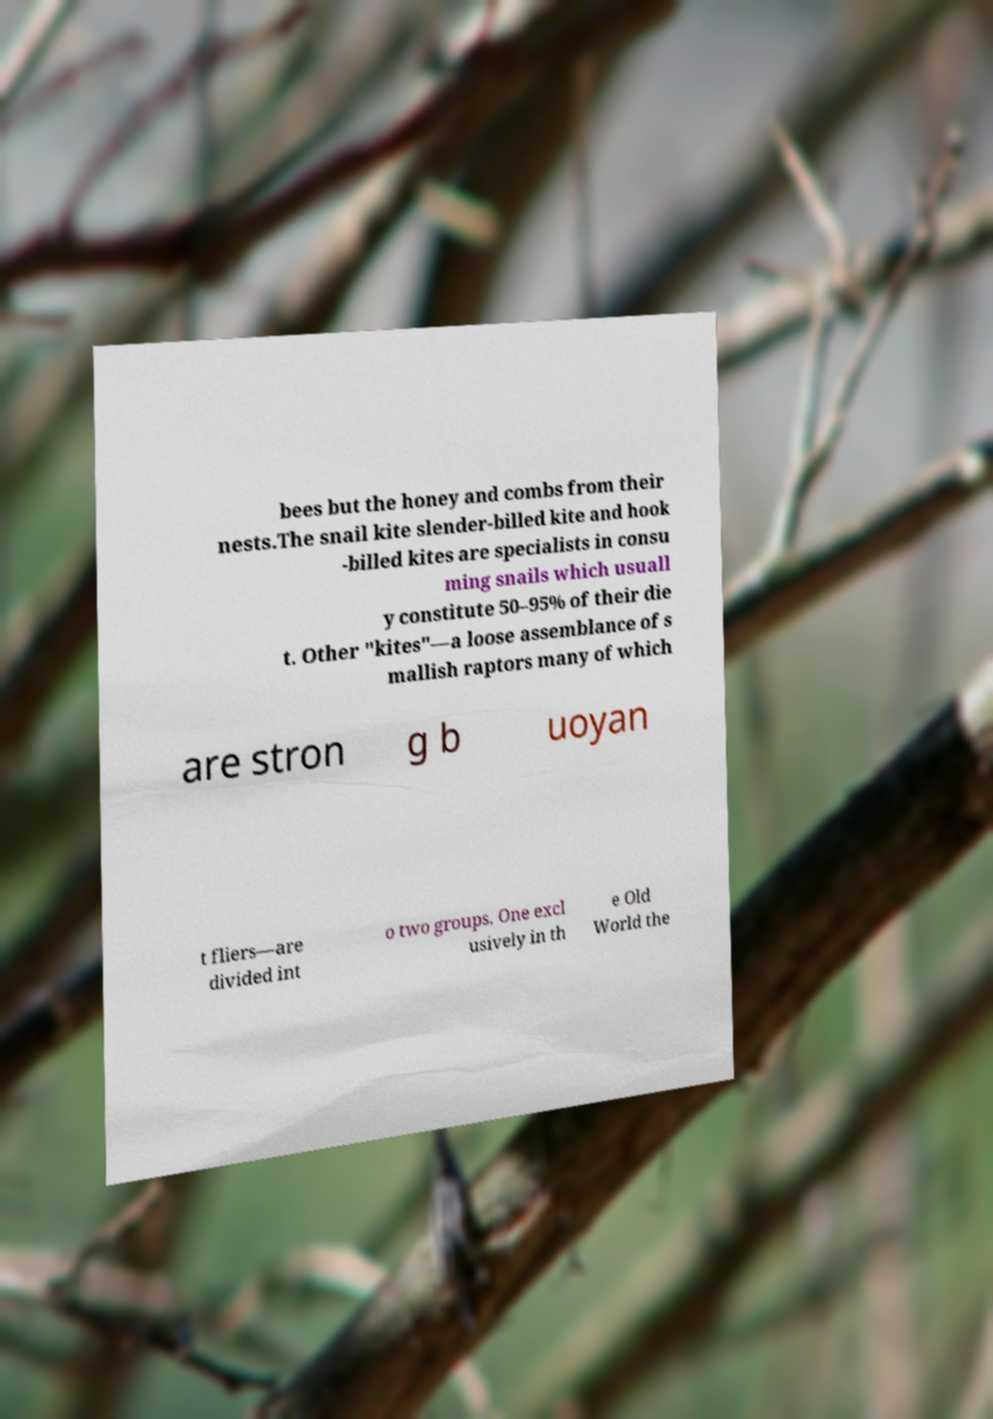For documentation purposes, I need the text within this image transcribed. Could you provide that? bees but the honey and combs from their nests.The snail kite slender-billed kite and hook -billed kites are specialists in consu ming snails which usuall y constitute 50–95% of their die t. Other "kites"—a loose assemblance of s mallish raptors many of which are stron g b uoyan t fliers—are divided int o two groups. One excl usively in th e Old World the 